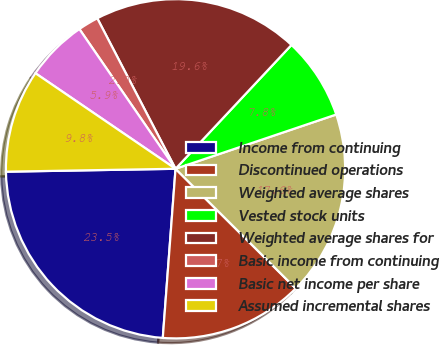Convert chart to OTSL. <chart><loc_0><loc_0><loc_500><loc_500><pie_chart><fcel>Income from continuing<fcel>Discontinued operations<fcel>Weighted average shares<fcel>Vested stock units<fcel>Weighted average shares for<fcel>Basic income from continuing<fcel>Basic net income per share<fcel>Assumed incremental shares<nl><fcel>23.53%<fcel>13.73%<fcel>17.65%<fcel>7.84%<fcel>19.61%<fcel>1.96%<fcel>5.88%<fcel>9.8%<nl></chart> 